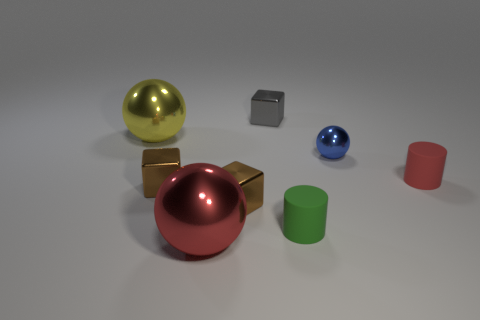Subtract all brown metal blocks. How many blocks are left? 1 Add 1 blue shiny spheres. How many objects exist? 9 Subtract all brown cubes. How many cubes are left? 1 Subtract 1 cylinders. How many cylinders are left? 1 Subtract all cylinders. How many objects are left? 6 Subtract all red cubes. Subtract all purple cylinders. How many cubes are left? 3 Subtract all brown spheres. How many gray cylinders are left? 0 Subtract all cyan matte cylinders. Subtract all tiny green things. How many objects are left? 7 Add 2 tiny blue metallic spheres. How many tiny blue metallic spheres are left? 3 Add 7 tiny cyan matte spheres. How many tiny cyan matte spheres exist? 7 